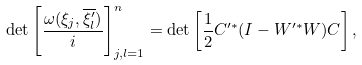<formula> <loc_0><loc_0><loc_500><loc_500>\det \left [ \frac { \omega ( \xi _ { j } , \overline { \xi ^ { \prime } _ { l } } ) } { i } \right ] _ { j , l = 1 } ^ { n } = \det \left [ \frac { 1 } { 2 } C ^ { \prime * } ( I - W ^ { \prime * } W ) C \right ] ,</formula> 